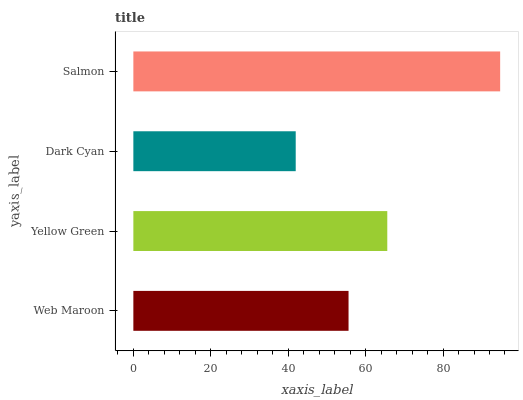Is Dark Cyan the minimum?
Answer yes or no. Yes. Is Salmon the maximum?
Answer yes or no. Yes. Is Yellow Green the minimum?
Answer yes or no. No. Is Yellow Green the maximum?
Answer yes or no. No. Is Yellow Green greater than Web Maroon?
Answer yes or no. Yes. Is Web Maroon less than Yellow Green?
Answer yes or no. Yes. Is Web Maroon greater than Yellow Green?
Answer yes or no. No. Is Yellow Green less than Web Maroon?
Answer yes or no. No. Is Yellow Green the high median?
Answer yes or no. Yes. Is Web Maroon the low median?
Answer yes or no. Yes. Is Salmon the high median?
Answer yes or no. No. Is Dark Cyan the low median?
Answer yes or no. No. 